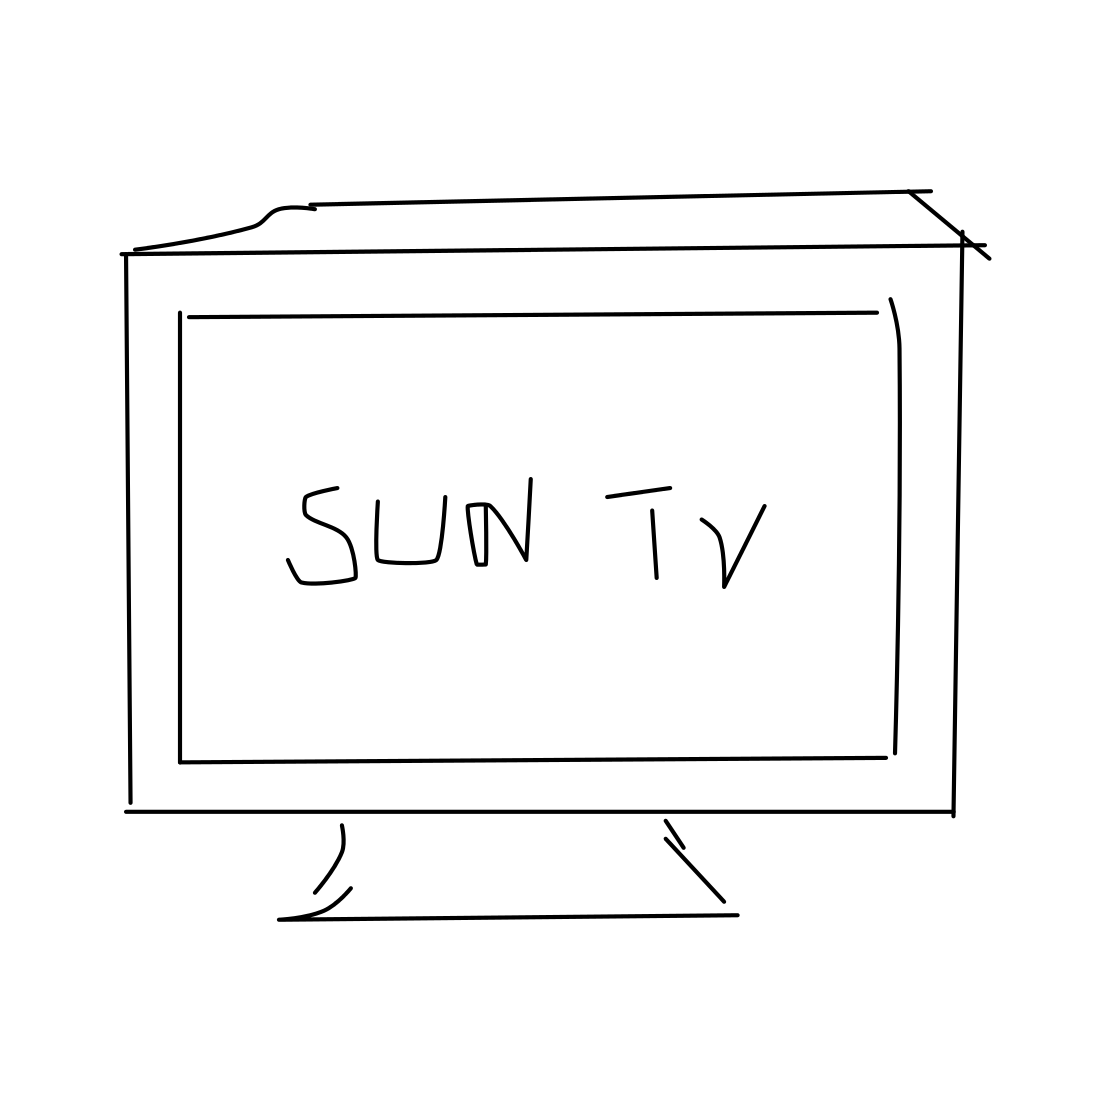Could you comment on the artistic style of this image? Certainly. The image is drawn in a minimalist and abstract style, using simple lines and shapes to convey the object without detail or shading, creating a modern and clean visual. Is this drawing meant to be realistic? The drawing is not intended to be highly realistic; it's more of a conceptual representation that captures the essence of a TV rather than its detailed features. 